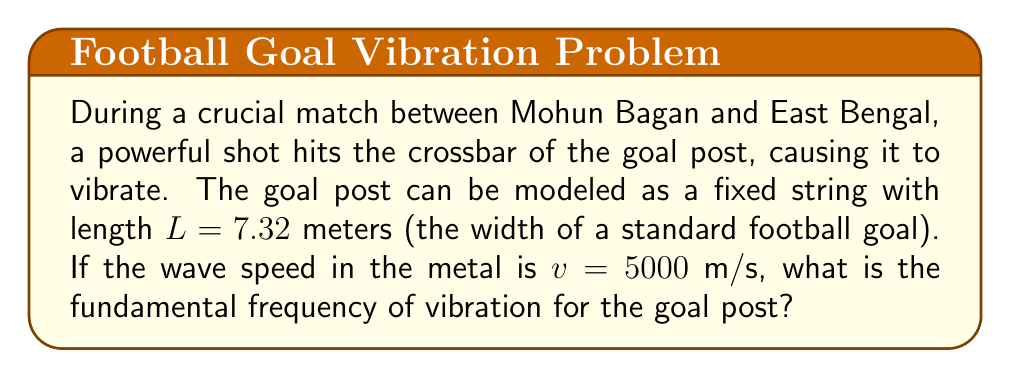Could you help me with this problem? To solve this problem, we'll use the wave equation for a fixed string:

1) The wave equation for a vibrating string is given by:

   $$\frac{\partial^2 y}{\partial t^2} = v^2 \frac{\partial^2 y}{\partial x^2}$$

2) For a string fixed at both ends (like the goal post), the boundary conditions are:

   $$y(0,t) = y(L,t) = 0$$

3) The general solution for this wave equation with these boundary conditions is:

   $$y(x,t) = \sum_{n=1}^{\infty} A_n \sin(\frac{n\pi x}{L}) \cos(\frac{n\pi v t}{L})$$

4) The fundamental frequency corresponds to $n=1$. The frequency $f$ is related to the angular frequency $\omega$ by:

   $$f = \frac{\omega}{2\pi}$$

5) For $n=1$, we have:

   $$\omega = \frac{\pi v}{L}$$

6) Substituting this into the frequency equation:

   $$f = \frac{v}{2L}$$

7) Now we can plug in our values:
   $v = 5000$ m/s
   $L = 7.32$ m

   $$f = \frac{5000}{2(7.32)} = 341.53$$ Hz

Therefore, the fundamental frequency of vibration for the goal post is approximately 341.53 Hz.
Answer: 341.53 Hz 